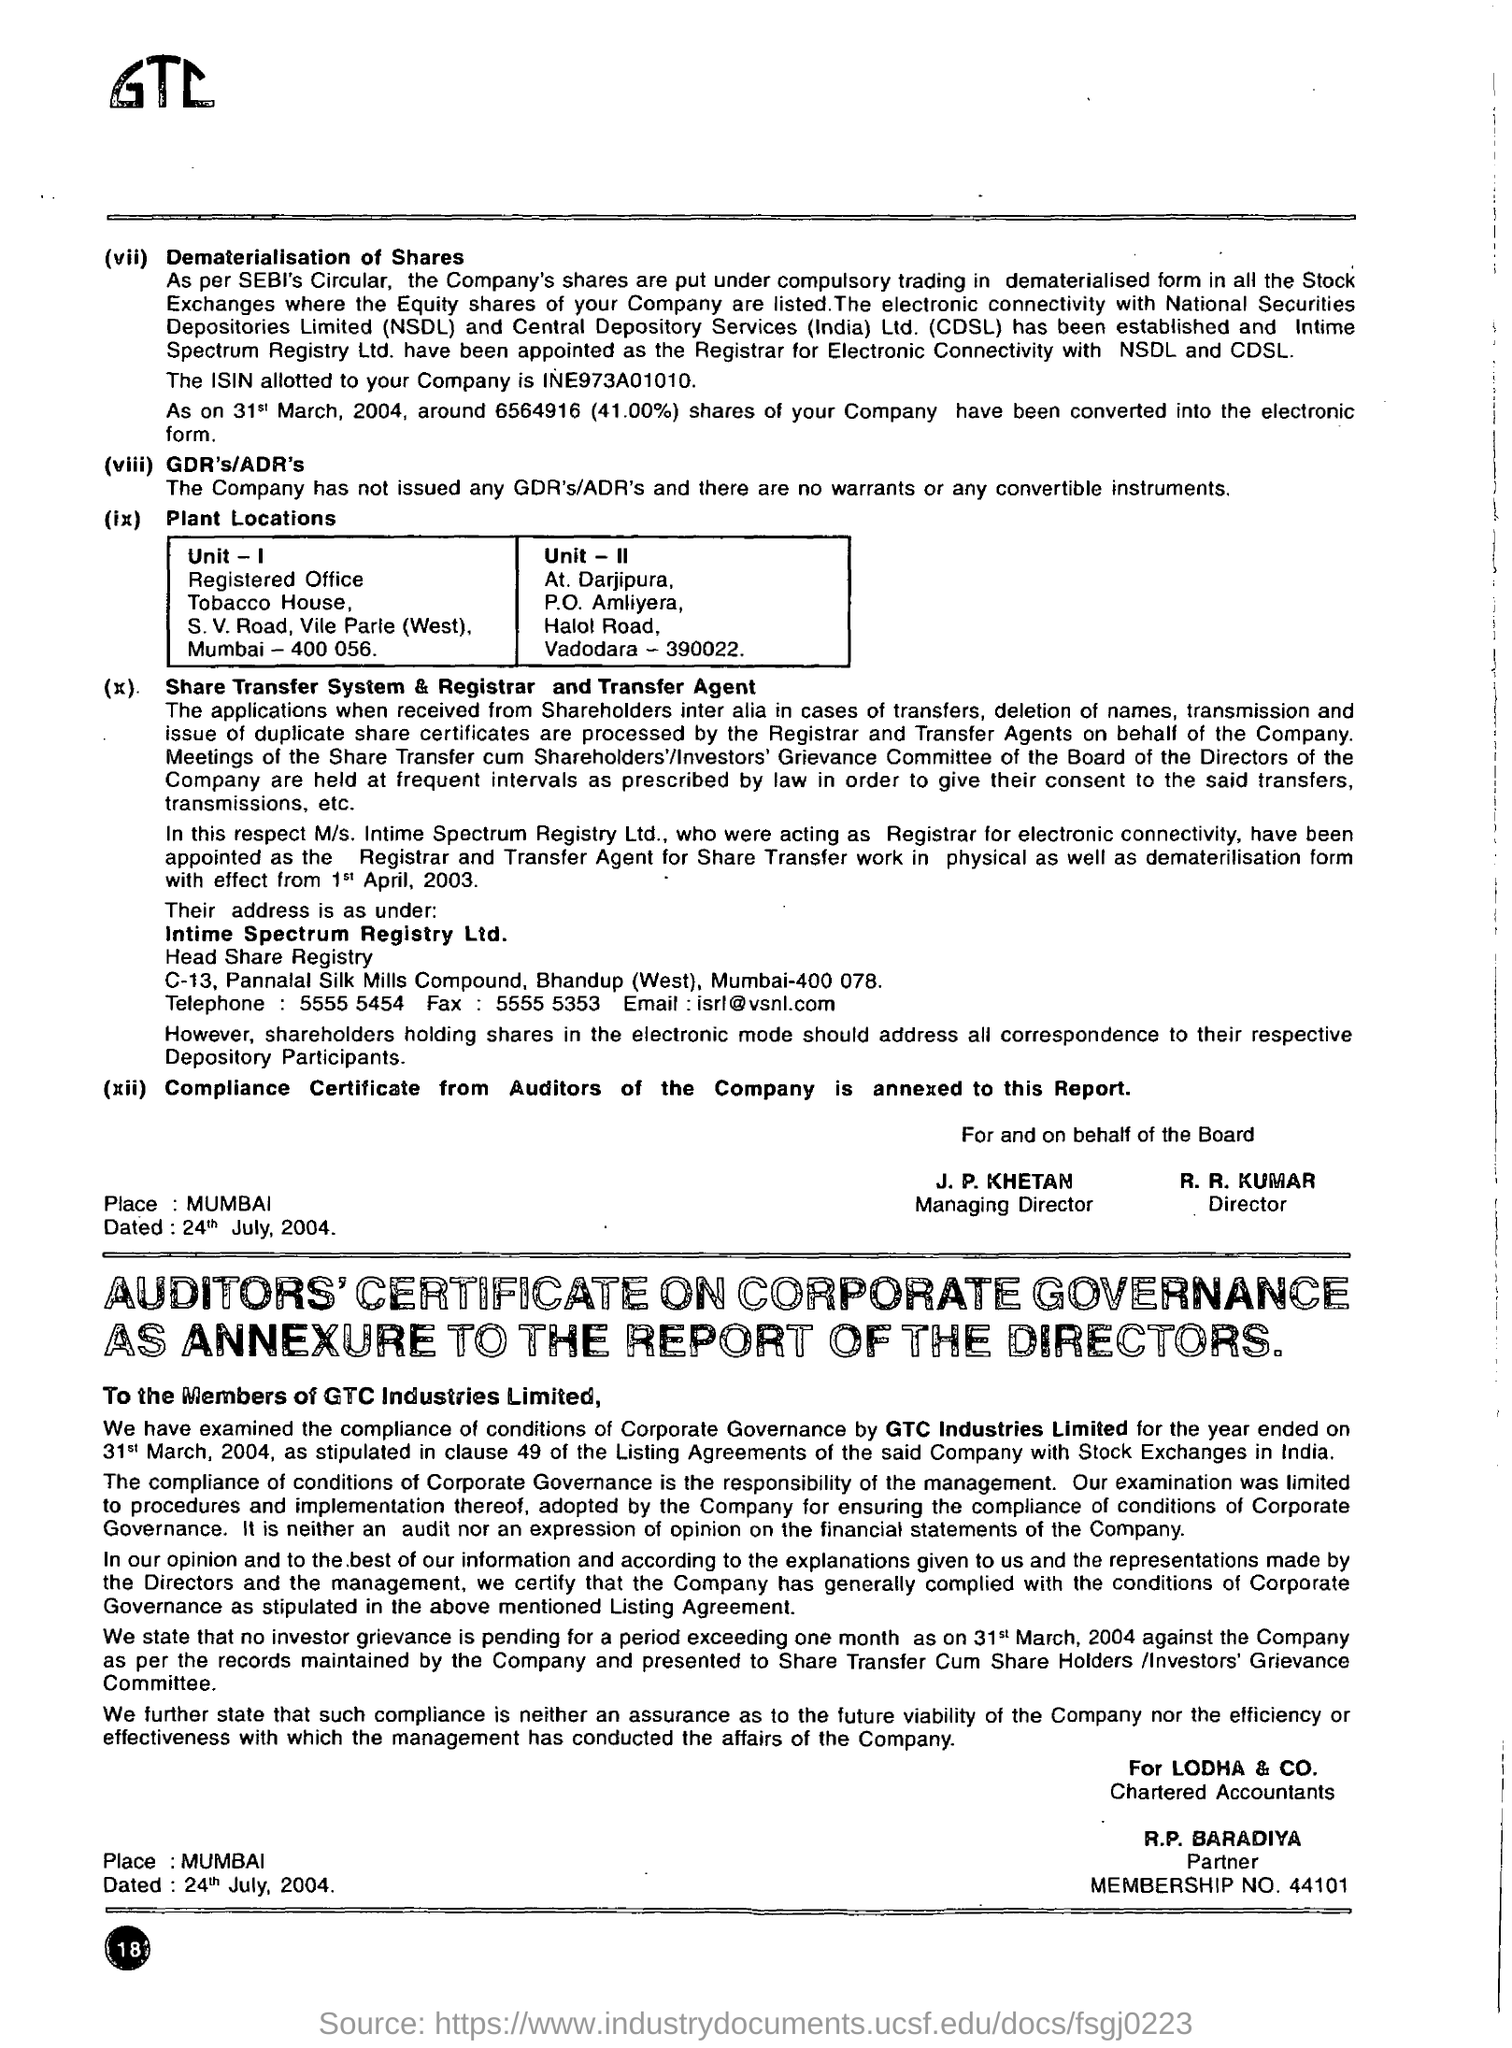Can you tell more about the auditors mentioned in this report? The auditors for GTC Industries Limited, as mentioned, are Lodha & Co., with R.P. Baradiya acting as the partner responsible for the audit. This firm oversees the evaluation of the company’s adherence to corporate governance standards and financial practices to ensure transparency and reliability in the company's financial reporting. 